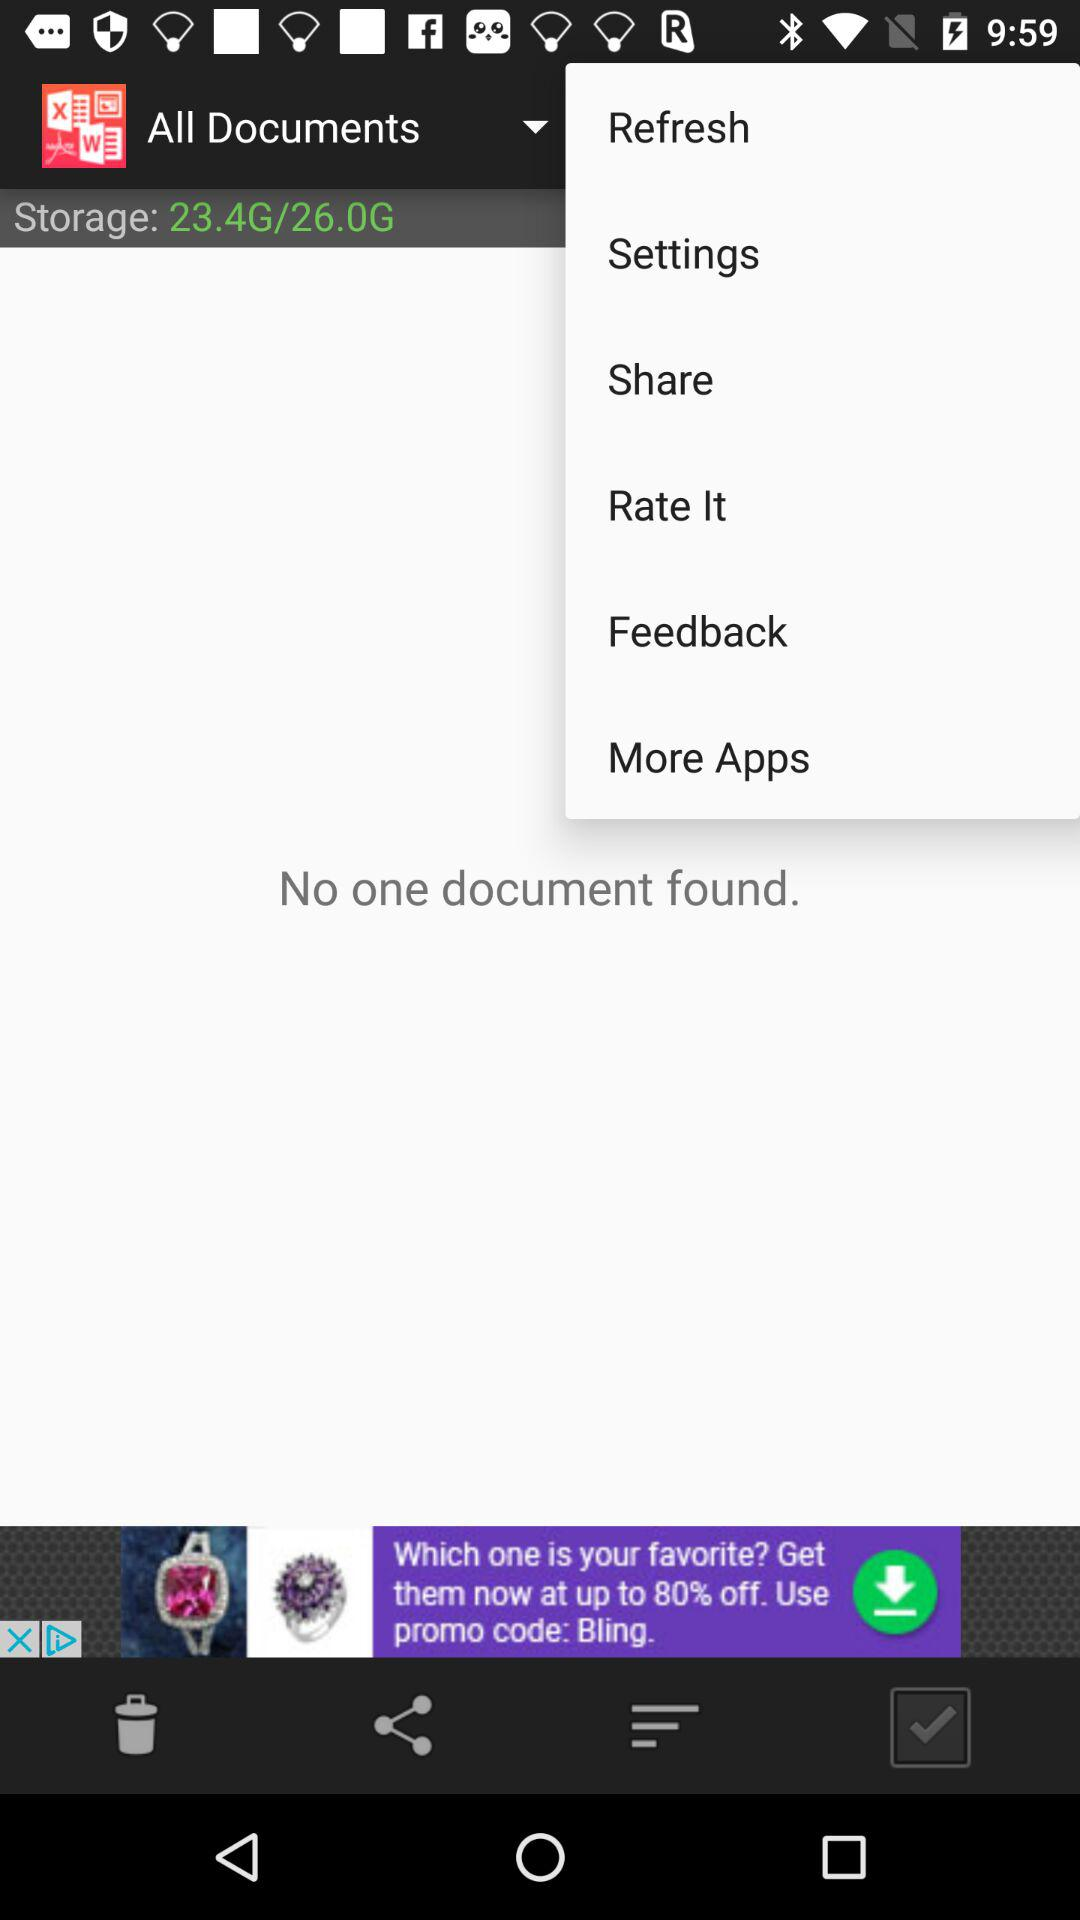How much free space is available?
Answer the question using a single word or phrase. 2.6G 